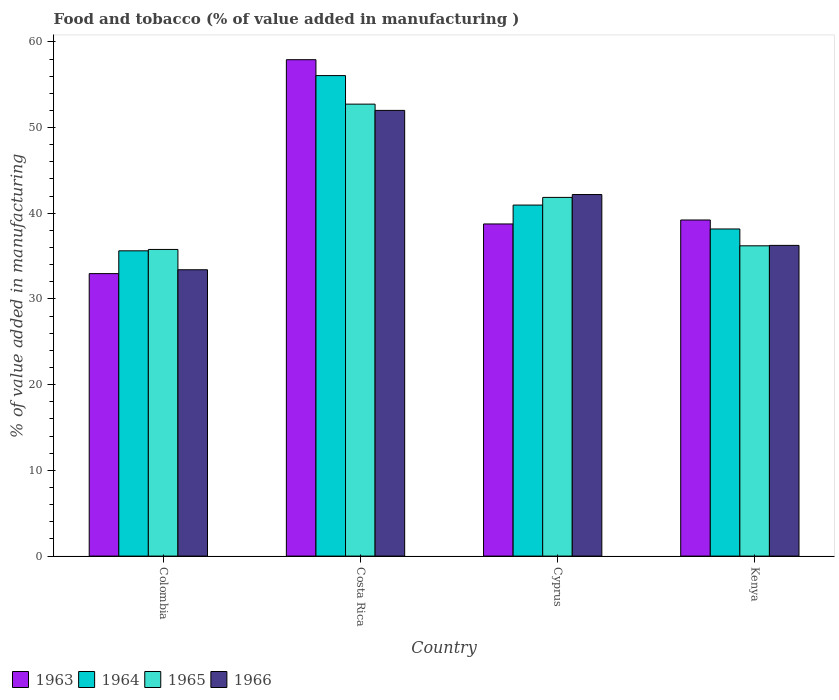How many different coloured bars are there?
Offer a very short reply. 4. How many groups of bars are there?
Provide a short and direct response. 4. Are the number of bars on each tick of the X-axis equal?
Ensure brevity in your answer.  Yes. How many bars are there on the 4th tick from the left?
Offer a terse response. 4. What is the label of the 3rd group of bars from the left?
Provide a succinct answer. Cyprus. What is the value added in manufacturing food and tobacco in 1966 in Costa Rica?
Your answer should be compact. 52. Across all countries, what is the maximum value added in manufacturing food and tobacco in 1963?
Offer a terse response. 57.92. Across all countries, what is the minimum value added in manufacturing food and tobacco in 1963?
Offer a very short reply. 32.96. In which country was the value added in manufacturing food and tobacco in 1965 maximum?
Your response must be concise. Costa Rica. In which country was the value added in manufacturing food and tobacco in 1966 minimum?
Make the answer very short. Colombia. What is the total value added in manufacturing food and tobacco in 1964 in the graph?
Offer a terse response. 170.81. What is the difference between the value added in manufacturing food and tobacco in 1965 in Costa Rica and that in Cyprus?
Make the answer very short. 10.88. What is the difference between the value added in manufacturing food and tobacco in 1963 in Kenya and the value added in manufacturing food and tobacco in 1964 in Costa Rica?
Provide a short and direct response. -16.85. What is the average value added in manufacturing food and tobacco in 1965 per country?
Offer a very short reply. 41.64. What is the difference between the value added in manufacturing food and tobacco of/in 1963 and value added in manufacturing food and tobacco of/in 1965 in Kenya?
Offer a terse response. 3.01. What is the ratio of the value added in manufacturing food and tobacco in 1965 in Cyprus to that in Kenya?
Provide a short and direct response. 1.16. What is the difference between the highest and the second highest value added in manufacturing food and tobacco in 1966?
Make the answer very short. -9.82. What is the difference between the highest and the lowest value added in manufacturing food and tobacco in 1964?
Your response must be concise. 20.45. Is the sum of the value added in manufacturing food and tobacco in 1966 in Colombia and Cyprus greater than the maximum value added in manufacturing food and tobacco in 1963 across all countries?
Provide a short and direct response. Yes. Is it the case that in every country, the sum of the value added in manufacturing food and tobacco in 1966 and value added in manufacturing food and tobacco in 1963 is greater than the sum of value added in manufacturing food and tobacco in 1965 and value added in manufacturing food and tobacco in 1964?
Provide a succinct answer. No. What does the 3rd bar from the left in Kenya represents?
Your answer should be very brief. 1965. What does the 3rd bar from the right in Costa Rica represents?
Keep it short and to the point. 1964. Is it the case that in every country, the sum of the value added in manufacturing food and tobacco in 1965 and value added in manufacturing food and tobacco in 1966 is greater than the value added in manufacturing food and tobacco in 1964?
Ensure brevity in your answer.  Yes. How many countries are there in the graph?
Your answer should be very brief. 4. What is the difference between two consecutive major ticks on the Y-axis?
Keep it short and to the point. 10. Are the values on the major ticks of Y-axis written in scientific E-notation?
Your answer should be compact. No. How many legend labels are there?
Your answer should be very brief. 4. What is the title of the graph?
Provide a succinct answer. Food and tobacco (% of value added in manufacturing ). Does "1962" appear as one of the legend labels in the graph?
Ensure brevity in your answer.  No. What is the label or title of the X-axis?
Provide a succinct answer. Country. What is the label or title of the Y-axis?
Your response must be concise. % of value added in manufacturing. What is the % of value added in manufacturing in 1963 in Colombia?
Offer a terse response. 32.96. What is the % of value added in manufacturing in 1964 in Colombia?
Offer a terse response. 35.62. What is the % of value added in manufacturing of 1965 in Colombia?
Make the answer very short. 35.78. What is the % of value added in manufacturing in 1966 in Colombia?
Make the answer very short. 33.41. What is the % of value added in manufacturing in 1963 in Costa Rica?
Keep it short and to the point. 57.92. What is the % of value added in manufacturing in 1964 in Costa Rica?
Provide a succinct answer. 56.07. What is the % of value added in manufacturing of 1965 in Costa Rica?
Provide a short and direct response. 52.73. What is the % of value added in manufacturing in 1966 in Costa Rica?
Keep it short and to the point. 52. What is the % of value added in manufacturing in 1963 in Cyprus?
Your answer should be very brief. 38.75. What is the % of value added in manufacturing of 1964 in Cyprus?
Offer a terse response. 40.96. What is the % of value added in manufacturing of 1965 in Cyprus?
Offer a very short reply. 41.85. What is the % of value added in manufacturing in 1966 in Cyprus?
Offer a very short reply. 42.19. What is the % of value added in manufacturing in 1963 in Kenya?
Ensure brevity in your answer.  39.22. What is the % of value added in manufacturing in 1964 in Kenya?
Offer a very short reply. 38.17. What is the % of value added in manufacturing in 1965 in Kenya?
Offer a terse response. 36.2. What is the % of value added in manufacturing in 1966 in Kenya?
Provide a succinct answer. 36.25. Across all countries, what is the maximum % of value added in manufacturing in 1963?
Your answer should be very brief. 57.92. Across all countries, what is the maximum % of value added in manufacturing of 1964?
Ensure brevity in your answer.  56.07. Across all countries, what is the maximum % of value added in manufacturing in 1965?
Keep it short and to the point. 52.73. Across all countries, what is the maximum % of value added in manufacturing of 1966?
Your answer should be very brief. 52. Across all countries, what is the minimum % of value added in manufacturing of 1963?
Provide a short and direct response. 32.96. Across all countries, what is the minimum % of value added in manufacturing in 1964?
Your answer should be very brief. 35.62. Across all countries, what is the minimum % of value added in manufacturing in 1965?
Keep it short and to the point. 35.78. Across all countries, what is the minimum % of value added in manufacturing of 1966?
Your answer should be very brief. 33.41. What is the total % of value added in manufacturing of 1963 in the graph?
Offer a very short reply. 168.85. What is the total % of value added in manufacturing of 1964 in the graph?
Give a very brief answer. 170.81. What is the total % of value added in manufacturing in 1965 in the graph?
Your answer should be very brief. 166.57. What is the total % of value added in manufacturing of 1966 in the graph?
Your response must be concise. 163.86. What is the difference between the % of value added in manufacturing of 1963 in Colombia and that in Costa Rica?
Provide a succinct answer. -24.96. What is the difference between the % of value added in manufacturing of 1964 in Colombia and that in Costa Rica?
Ensure brevity in your answer.  -20.45. What is the difference between the % of value added in manufacturing in 1965 in Colombia and that in Costa Rica?
Give a very brief answer. -16.95. What is the difference between the % of value added in manufacturing of 1966 in Colombia and that in Costa Rica?
Provide a short and direct response. -18.59. What is the difference between the % of value added in manufacturing in 1963 in Colombia and that in Cyprus?
Your answer should be compact. -5.79. What is the difference between the % of value added in manufacturing of 1964 in Colombia and that in Cyprus?
Your response must be concise. -5.34. What is the difference between the % of value added in manufacturing in 1965 in Colombia and that in Cyprus?
Ensure brevity in your answer.  -6.07. What is the difference between the % of value added in manufacturing in 1966 in Colombia and that in Cyprus?
Your response must be concise. -8.78. What is the difference between the % of value added in manufacturing of 1963 in Colombia and that in Kenya?
Keep it short and to the point. -6.26. What is the difference between the % of value added in manufacturing in 1964 in Colombia and that in Kenya?
Provide a short and direct response. -2.55. What is the difference between the % of value added in manufacturing in 1965 in Colombia and that in Kenya?
Provide a succinct answer. -0.42. What is the difference between the % of value added in manufacturing of 1966 in Colombia and that in Kenya?
Provide a short and direct response. -2.84. What is the difference between the % of value added in manufacturing in 1963 in Costa Rica and that in Cyprus?
Your response must be concise. 19.17. What is the difference between the % of value added in manufacturing in 1964 in Costa Rica and that in Cyprus?
Provide a short and direct response. 15.11. What is the difference between the % of value added in manufacturing of 1965 in Costa Rica and that in Cyprus?
Your answer should be very brief. 10.88. What is the difference between the % of value added in manufacturing in 1966 in Costa Rica and that in Cyprus?
Provide a succinct answer. 9.82. What is the difference between the % of value added in manufacturing in 1963 in Costa Rica and that in Kenya?
Your response must be concise. 18.7. What is the difference between the % of value added in manufacturing in 1964 in Costa Rica and that in Kenya?
Offer a terse response. 17.9. What is the difference between the % of value added in manufacturing of 1965 in Costa Rica and that in Kenya?
Make the answer very short. 16.53. What is the difference between the % of value added in manufacturing of 1966 in Costa Rica and that in Kenya?
Your answer should be very brief. 15.75. What is the difference between the % of value added in manufacturing of 1963 in Cyprus and that in Kenya?
Provide a succinct answer. -0.46. What is the difference between the % of value added in manufacturing of 1964 in Cyprus and that in Kenya?
Offer a very short reply. 2.79. What is the difference between the % of value added in manufacturing in 1965 in Cyprus and that in Kenya?
Offer a very short reply. 5.65. What is the difference between the % of value added in manufacturing of 1966 in Cyprus and that in Kenya?
Make the answer very short. 5.93. What is the difference between the % of value added in manufacturing in 1963 in Colombia and the % of value added in manufacturing in 1964 in Costa Rica?
Make the answer very short. -23.11. What is the difference between the % of value added in manufacturing of 1963 in Colombia and the % of value added in manufacturing of 1965 in Costa Rica?
Your answer should be very brief. -19.77. What is the difference between the % of value added in manufacturing in 1963 in Colombia and the % of value added in manufacturing in 1966 in Costa Rica?
Your answer should be very brief. -19.04. What is the difference between the % of value added in manufacturing of 1964 in Colombia and the % of value added in manufacturing of 1965 in Costa Rica?
Provide a short and direct response. -17.11. What is the difference between the % of value added in manufacturing of 1964 in Colombia and the % of value added in manufacturing of 1966 in Costa Rica?
Ensure brevity in your answer.  -16.38. What is the difference between the % of value added in manufacturing of 1965 in Colombia and the % of value added in manufacturing of 1966 in Costa Rica?
Keep it short and to the point. -16.22. What is the difference between the % of value added in manufacturing of 1963 in Colombia and the % of value added in manufacturing of 1964 in Cyprus?
Provide a short and direct response. -8. What is the difference between the % of value added in manufacturing of 1963 in Colombia and the % of value added in manufacturing of 1965 in Cyprus?
Your response must be concise. -8.89. What is the difference between the % of value added in manufacturing of 1963 in Colombia and the % of value added in manufacturing of 1966 in Cyprus?
Ensure brevity in your answer.  -9.23. What is the difference between the % of value added in manufacturing of 1964 in Colombia and the % of value added in manufacturing of 1965 in Cyprus?
Keep it short and to the point. -6.23. What is the difference between the % of value added in manufacturing in 1964 in Colombia and the % of value added in manufacturing in 1966 in Cyprus?
Provide a short and direct response. -6.57. What is the difference between the % of value added in manufacturing in 1965 in Colombia and the % of value added in manufacturing in 1966 in Cyprus?
Keep it short and to the point. -6.41. What is the difference between the % of value added in manufacturing in 1963 in Colombia and the % of value added in manufacturing in 1964 in Kenya?
Keep it short and to the point. -5.21. What is the difference between the % of value added in manufacturing in 1963 in Colombia and the % of value added in manufacturing in 1965 in Kenya?
Your answer should be very brief. -3.24. What is the difference between the % of value added in manufacturing in 1963 in Colombia and the % of value added in manufacturing in 1966 in Kenya?
Keep it short and to the point. -3.29. What is the difference between the % of value added in manufacturing in 1964 in Colombia and the % of value added in manufacturing in 1965 in Kenya?
Your answer should be very brief. -0.58. What is the difference between the % of value added in manufacturing in 1964 in Colombia and the % of value added in manufacturing in 1966 in Kenya?
Offer a very short reply. -0.63. What is the difference between the % of value added in manufacturing of 1965 in Colombia and the % of value added in manufacturing of 1966 in Kenya?
Provide a short and direct response. -0.47. What is the difference between the % of value added in manufacturing of 1963 in Costa Rica and the % of value added in manufacturing of 1964 in Cyprus?
Your answer should be very brief. 16.96. What is the difference between the % of value added in manufacturing in 1963 in Costa Rica and the % of value added in manufacturing in 1965 in Cyprus?
Offer a very short reply. 16.07. What is the difference between the % of value added in manufacturing of 1963 in Costa Rica and the % of value added in manufacturing of 1966 in Cyprus?
Offer a very short reply. 15.73. What is the difference between the % of value added in manufacturing in 1964 in Costa Rica and the % of value added in manufacturing in 1965 in Cyprus?
Ensure brevity in your answer.  14.21. What is the difference between the % of value added in manufacturing of 1964 in Costa Rica and the % of value added in manufacturing of 1966 in Cyprus?
Offer a very short reply. 13.88. What is the difference between the % of value added in manufacturing of 1965 in Costa Rica and the % of value added in manufacturing of 1966 in Cyprus?
Keep it short and to the point. 10.55. What is the difference between the % of value added in manufacturing in 1963 in Costa Rica and the % of value added in manufacturing in 1964 in Kenya?
Offer a very short reply. 19.75. What is the difference between the % of value added in manufacturing in 1963 in Costa Rica and the % of value added in manufacturing in 1965 in Kenya?
Offer a terse response. 21.72. What is the difference between the % of value added in manufacturing in 1963 in Costa Rica and the % of value added in manufacturing in 1966 in Kenya?
Offer a terse response. 21.67. What is the difference between the % of value added in manufacturing of 1964 in Costa Rica and the % of value added in manufacturing of 1965 in Kenya?
Make the answer very short. 19.86. What is the difference between the % of value added in manufacturing in 1964 in Costa Rica and the % of value added in manufacturing in 1966 in Kenya?
Your answer should be compact. 19.81. What is the difference between the % of value added in manufacturing in 1965 in Costa Rica and the % of value added in manufacturing in 1966 in Kenya?
Offer a terse response. 16.48. What is the difference between the % of value added in manufacturing of 1963 in Cyprus and the % of value added in manufacturing of 1964 in Kenya?
Make the answer very short. 0.59. What is the difference between the % of value added in manufacturing of 1963 in Cyprus and the % of value added in manufacturing of 1965 in Kenya?
Provide a short and direct response. 2.55. What is the difference between the % of value added in manufacturing in 1963 in Cyprus and the % of value added in manufacturing in 1966 in Kenya?
Provide a succinct answer. 2.5. What is the difference between the % of value added in manufacturing in 1964 in Cyprus and the % of value added in manufacturing in 1965 in Kenya?
Offer a very short reply. 4.75. What is the difference between the % of value added in manufacturing in 1964 in Cyprus and the % of value added in manufacturing in 1966 in Kenya?
Your answer should be very brief. 4.7. What is the difference between the % of value added in manufacturing of 1965 in Cyprus and the % of value added in manufacturing of 1966 in Kenya?
Give a very brief answer. 5.6. What is the average % of value added in manufacturing in 1963 per country?
Give a very brief answer. 42.21. What is the average % of value added in manufacturing of 1964 per country?
Ensure brevity in your answer.  42.7. What is the average % of value added in manufacturing in 1965 per country?
Your answer should be very brief. 41.64. What is the average % of value added in manufacturing of 1966 per country?
Your response must be concise. 40.96. What is the difference between the % of value added in manufacturing of 1963 and % of value added in manufacturing of 1964 in Colombia?
Your answer should be very brief. -2.66. What is the difference between the % of value added in manufacturing of 1963 and % of value added in manufacturing of 1965 in Colombia?
Offer a terse response. -2.82. What is the difference between the % of value added in manufacturing of 1963 and % of value added in manufacturing of 1966 in Colombia?
Keep it short and to the point. -0.45. What is the difference between the % of value added in manufacturing in 1964 and % of value added in manufacturing in 1965 in Colombia?
Ensure brevity in your answer.  -0.16. What is the difference between the % of value added in manufacturing of 1964 and % of value added in manufacturing of 1966 in Colombia?
Your answer should be very brief. 2.21. What is the difference between the % of value added in manufacturing in 1965 and % of value added in manufacturing in 1966 in Colombia?
Your response must be concise. 2.37. What is the difference between the % of value added in manufacturing of 1963 and % of value added in manufacturing of 1964 in Costa Rica?
Your answer should be very brief. 1.85. What is the difference between the % of value added in manufacturing in 1963 and % of value added in manufacturing in 1965 in Costa Rica?
Your answer should be very brief. 5.19. What is the difference between the % of value added in manufacturing in 1963 and % of value added in manufacturing in 1966 in Costa Rica?
Offer a very short reply. 5.92. What is the difference between the % of value added in manufacturing in 1964 and % of value added in manufacturing in 1965 in Costa Rica?
Offer a terse response. 3.33. What is the difference between the % of value added in manufacturing in 1964 and % of value added in manufacturing in 1966 in Costa Rica?
Provide a succinct answer. 4.06. What is the difference between the % of value added in manufacturing of 1965 and % of value added in manufacturing of 1966 in Costa Rica?
Provide a short and direct response. 0.73. What is the difference between the % of value added in manufacturing in 1963 and % of value added in manufacturing in 1964 in Cyprus?
Your answer should be compact. -2.2. What is the difference between the % of value added in manufacturing in 1963 and % of value added in manufacturing in 1965 in Cyprus?
Give a very brief answer. -3.1. What is the difference between the % of value added in manufacturing of 1963 and % of value added in manufacturing of 1966 in Cyprus?
Provide a short and direct response. -3.43. What is the difference between the % of value added in manufacturing of 1964 and % of value added in manufacturing of 1965 in Cyprus?
Give a very brief answer. -0.9. What is the difference between the % of value added in manufacturing of 1964 and % of value added in manufacturing of 1966 in Cyprus?
Your answer should be very brief. -1.23. What is the difference between the % of value added in manufacturing in 1963 and % of value added in manufacturing in 1964 in Kenya?
Offer a terse response. 1.05. What is the difference between the % of value added in manufacturing of 1963 and % of value added in manufacturing of 1965 in Kenya?
Offer a terse response. 3.01. What is the difference between the % of value added in manufacturing in 1963 and % of value added in manufacturing in 1966 in Kenya?
Ensure brevity in your answer.  2.96. What is the difference between the % of value added in manufacturing in 1964 and % of value added in manufacturing in 1965 in Kenya?
Provide a succinct answer. 1.96. What is the difference between the % of value added in manufacturing in 1964 and % of value added in manufacturing in 1966 in Kenya?
Provide a succinct answer. 1.91. What is the difference between the % of value added in manufacturing of 1965 and % of value added in manufacturing of 1966 in Kenya?
Make the answer very short. -0.05. What is the ratio of the % of value added in manufacturing in 1963 in Colombia to that in Costa Rica?
Give a very brief answer. 0.57. What is the ratio of the % of value added in manufacturing of 1964 in Colombia to that in Costa Rica?
Keep it short and to the point. 0.64. What is the ratio of the % of value added in manufacturing of 1965 in Colombia to that in Costa Rica?
Your answer should be compact. 0.68. What is the ratio of the % of value added in manufacturing in 1966 in Colombia to that in Costa Rica?
Provide a short and direct response. 0.64. What is the ratio of the % of value added in manufacturing in 1963 in Colombia to that in Cyprus?
Your response must be concise. 0.85. What is the ratio of the % of value added in manufacturing in 1964 in Colombia to that in Cyprus?
Your answer should be compact. 0.87. What is the ratio of the % of value added in manufacturing in 1965 in Colombia to that in Cyprus?
Offer a very short reply. 0.85. What is the ratio of the % of value added in manufacturing of 1966 in Colombia to that in Cyprus?
Offer a terse response. 0.79. What is the ratio of the % of value added in manufacturing of 1963 in Colombia to that in Kenya?
Ensure brevity in your answer.  0.84. What is the ratio of the % of value added in manufacturing in 1964 in Colombia to that in Kenya?
Offer a terse response. 0.93. What is the ratio of the % of value added in manufacturing in 1965 in Colombia to that in Kenya?
Make the answer very short. 0.99. What is the ratio of the % of value added in manufacturing of 1966 in Colombia to that in Kenya?
Give a very brief answer. 0.92. What is the ratio of the % of value added in manufacturing in 1963 in Costa Rica to that in Cyprus?
Provide a short and direct response. 1.49. What is the ratio of the % of value added in manufacturing in 1964 in Costa Rica to that in Cyprus?
Make the answer very short. 1.37. What is the ratio of the % of value added in manufacturing of 1965 in Costa Rica to that in Cyprus?
Ensure brevity in your answer.  1.26. What is the ratio of the % of value added in manufacturing of 1966 in Costa Rica to that in Cyprus?
Your response must be concise. 1.23. What is the ratio of the % of value added in manufacturing in 1963 in Costa Rica to that in Kenya?
Offer a terse response. 1.48. What is the ratio of the % of value added in manufacturing of 1964 in Costa Rica to that in Kenya?
Make the answer very short. 1.47. What is the ratio of the % of value added in manufacturing in 1965 in Costa Rica to that in Kenya?
Give a very brief answer. 1.46. What is the ratio of the % of value added in manufacturing in 1966 in Costa Rica to that in Kenya?
Your answer should be compact. 1.43. What is the ratio of the % of value added in manufacturing of 1963 in Cyprus to that in Kenya?
Offer a very short reply. 0.99. What is the ratio of the % of value added in manufacturing in 1964 in Cyprus to that in Kenya?
Your answer should be compact. 1.07. What is the ratio of the % of value added in manufacturing in 1965 in Cyprus to that in Kenya?
Your answer should be compact. 1.16. What is the ratio of the % of value added in manufacturing of 1966 in Cyprus to that in Kenya?
Make the answer very short. 1.16. What is the difference between the highest and the second highest % of value added in manufacturing of 1963?
Provide a succinct answer. 18.7. What is the difference between the highest and the second highest % of value added in manufacturing of 1964?
Your answer should be very brief. 15.11. What is the difference between the highest and the second highest % of value added in manufacturing of 1965?
Your answer should be very brief. 10.88. What is the difference between the highest and the second highest % of value added in manufacturing in 1966?
Your answer should be compact. 9.82. What is the difference between the highest and the lowest % of value added in manufacturing of 1963?
Your answer should be very brief. 24.96. What is the difference between the highest and the lowest % of value added in manufacturing of 1964?
Keep it short and to the point. 20.45. What is the difference between the highest and the lowest % of value added in manufacturing in 1965?
Your answer should be compact. 16.95. What is the difference between the highest and the lowest % of value added in manufacturing of 1966?
Provide a succinct answer. 18.59. 